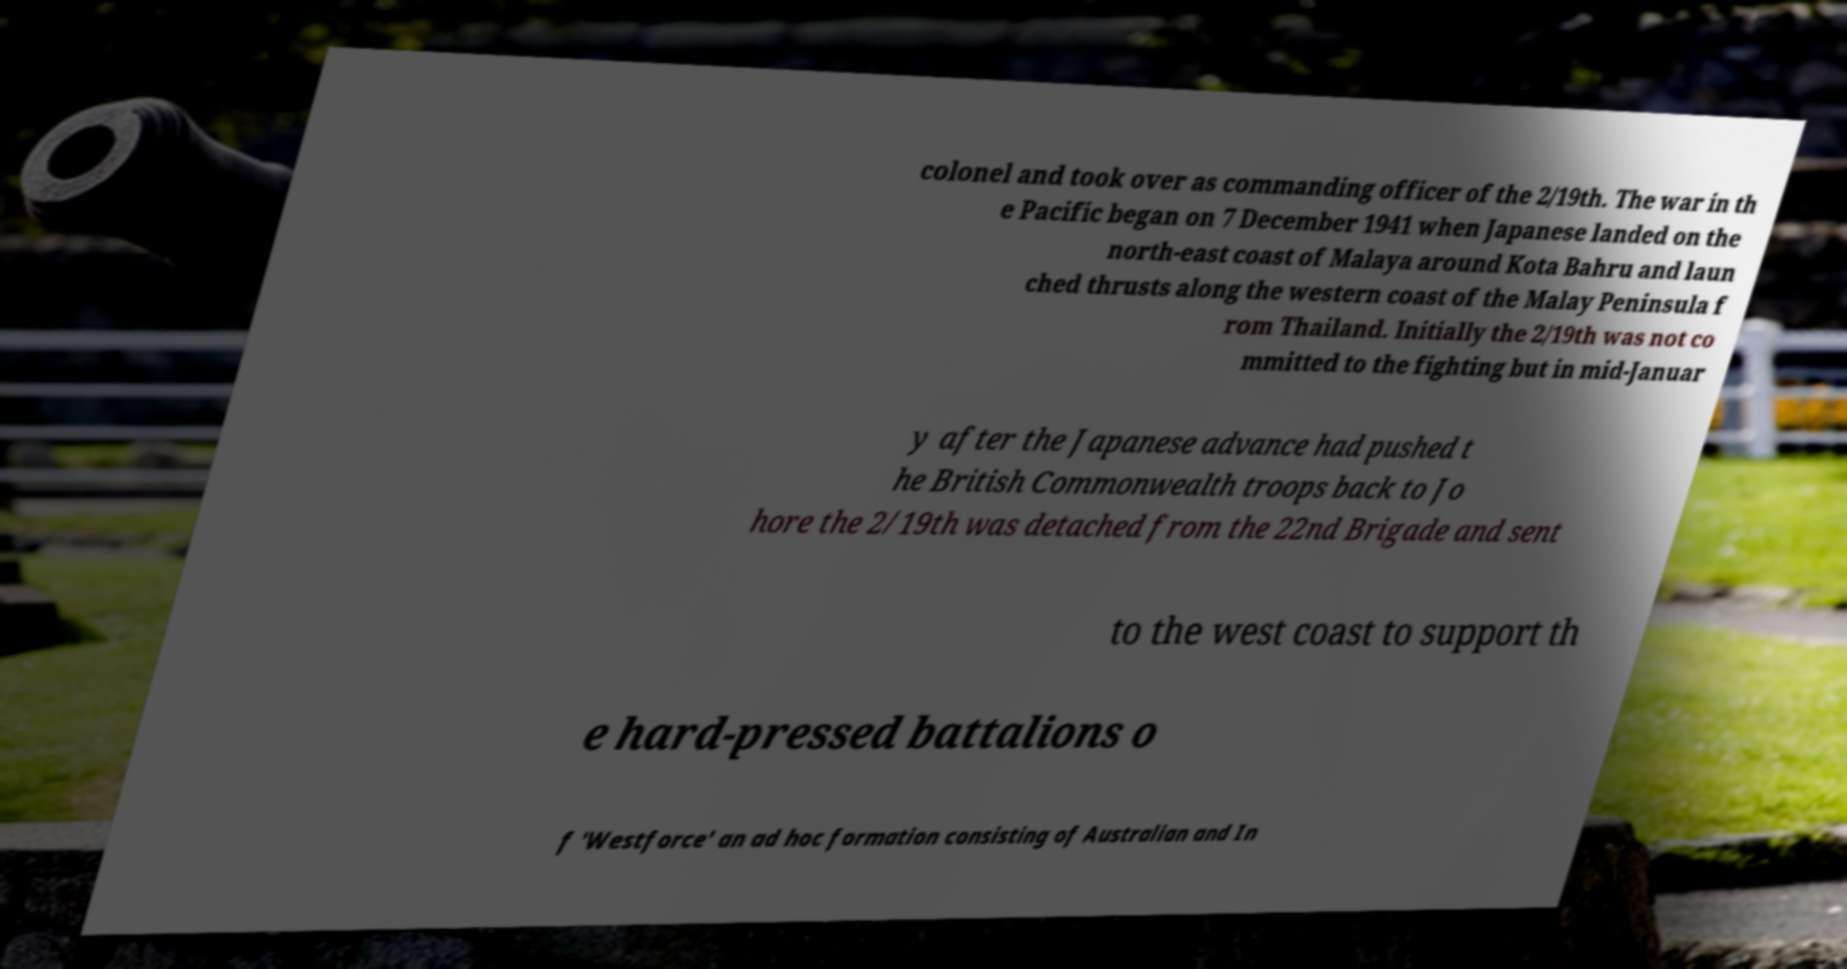What messages or text are displayed in this image? I need them in a readable, typed format. colonel and took over as commanding officer of the 2/19th. The war in th e Pacific began on 7 December 1941 when Japanese landed on the north-east coast of Malaya around Kota Bahru and laun ched thrusts along the western coast of the Malay Peninsula f rom Thailand. Initially the 2/19th was not co mmitted to the fighting but in mid-Januar y after the Japanese advance had pushed t he British Commonwealth troops back to Jo hore the 2/19th was detached from the 22nd Brigade and sent to the west coast to support th e hard-pressed battalions o f 'Westforce' an ad hoc formation consisting of Australian and In 